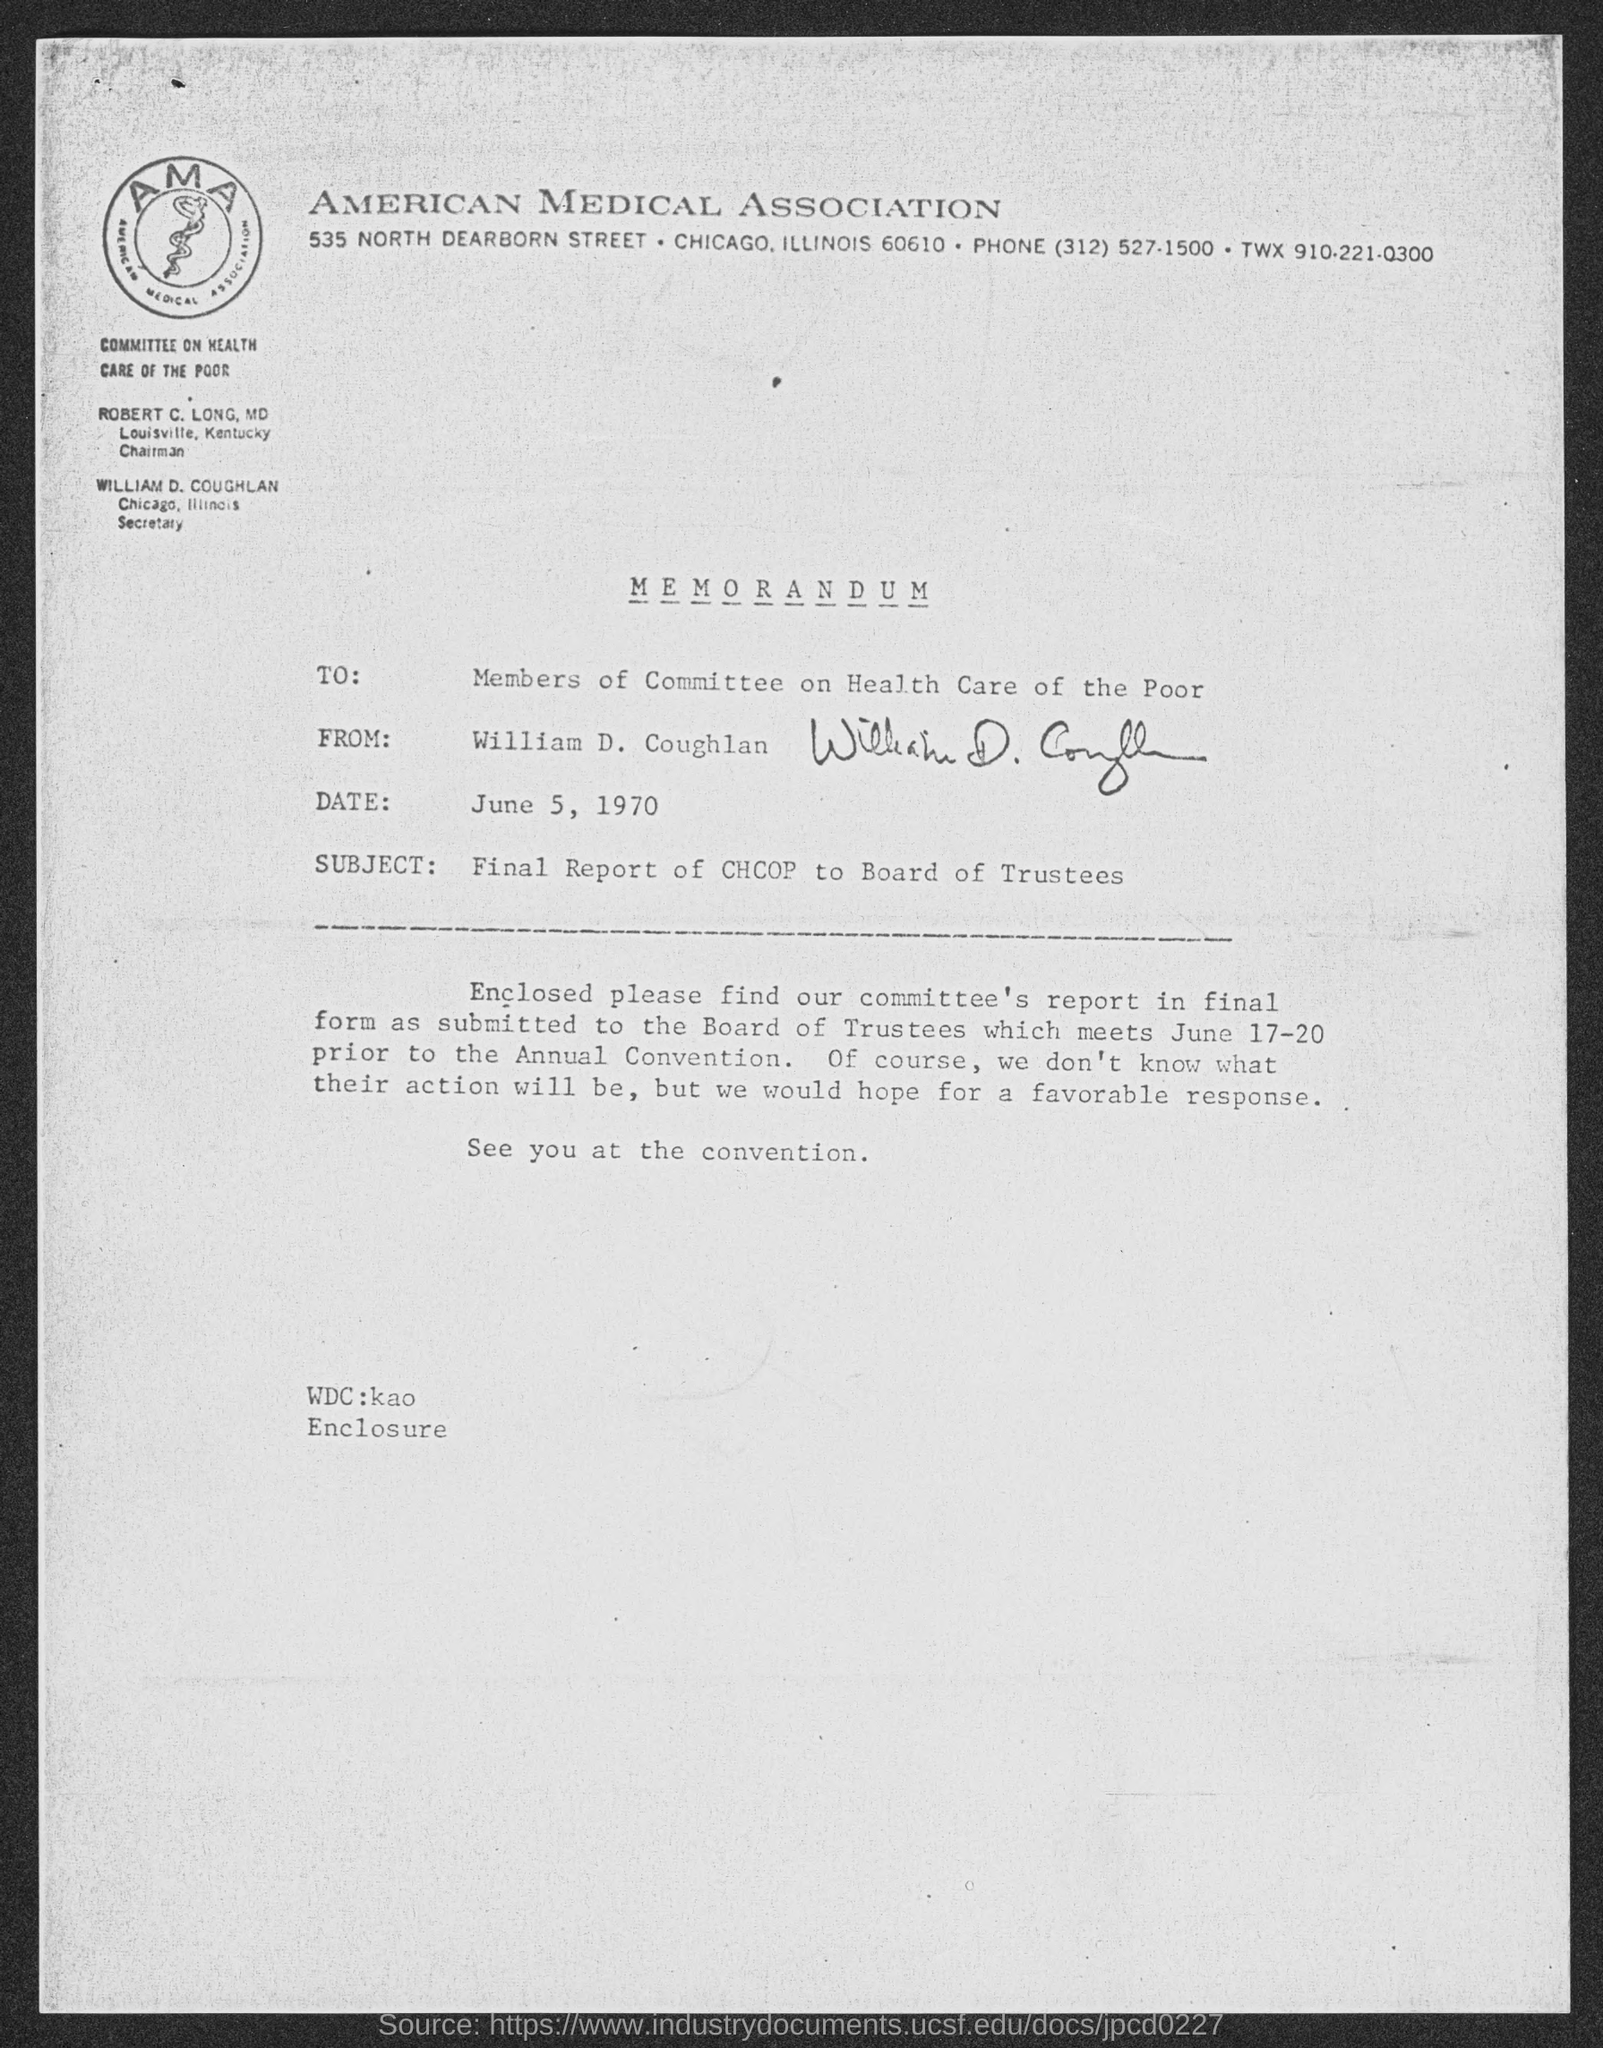Outline some significant characteristics in this image. The document is from William D. Coughlan. The subject of the document is the Final Report of the Chief Human Capital Officer (CHCOP) to the Board of Trustees. This is a memorandum, a type of documentation. The memorandum is addressed to the members of the committee on health care for the poor. The American Medical Association is mentioned. 